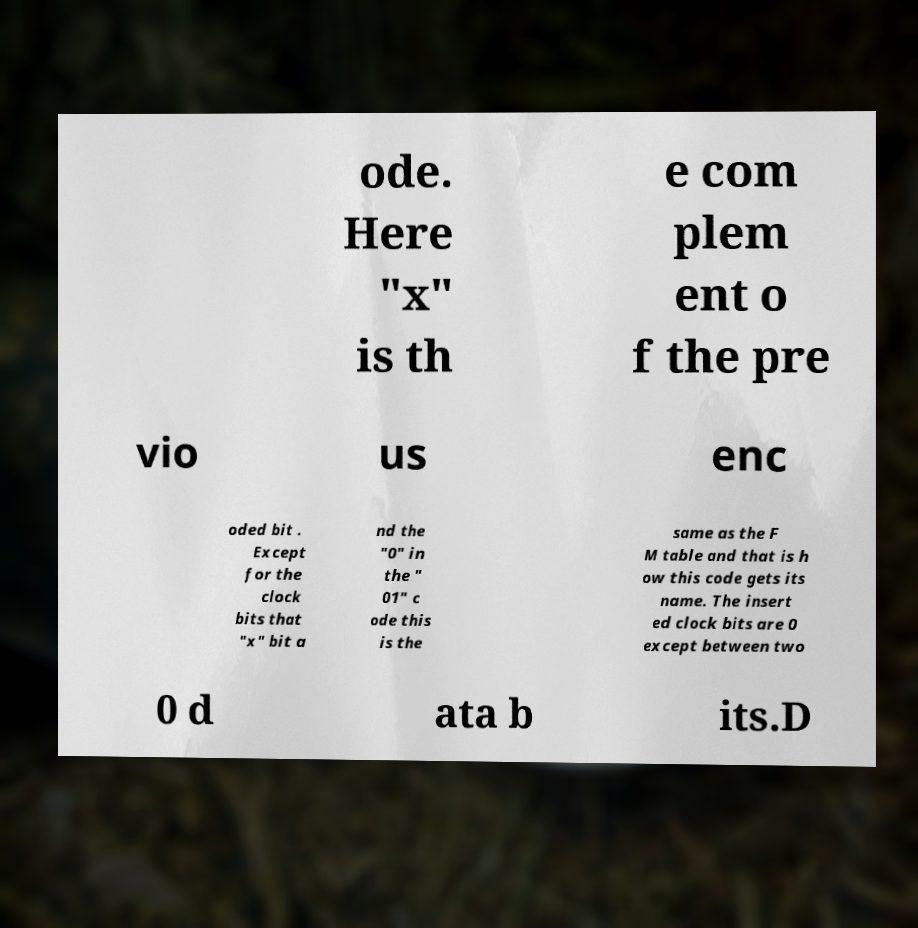What messages or text are displayed in this image? I need them in a readable, typed format. ode. Here "x" is th e com plem ent o f the pre vio us enc oded bit . Except for the clock bits that "x" bit a nd the "0" in the " 01" c ode this is the same as the F M table and that is h ow this code gets its name. The insert ed clock bits are 0 except between two 0 d ata b its.D 